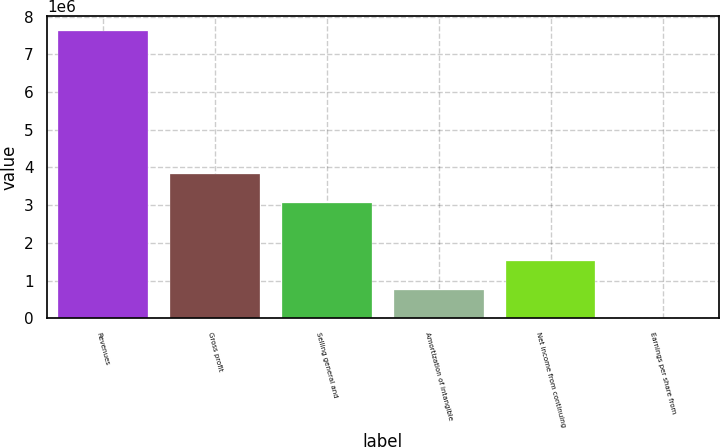<chart> <loc_0><loc_0><loc_500><loc_500><bar_chart><fcel>Revenues<fcel>Gross profit<fcel>Selling general and<fcel>Amortization of intangible<fcel>Net income from continuing<fcel>Earnings per share from<nl><fcel>7.62931e+06<fcel>3.81466e+06<fcel>3.05173e+06<fcel>762933<fcel>1.52586e+06<fcel>1.95<nl></chart> 